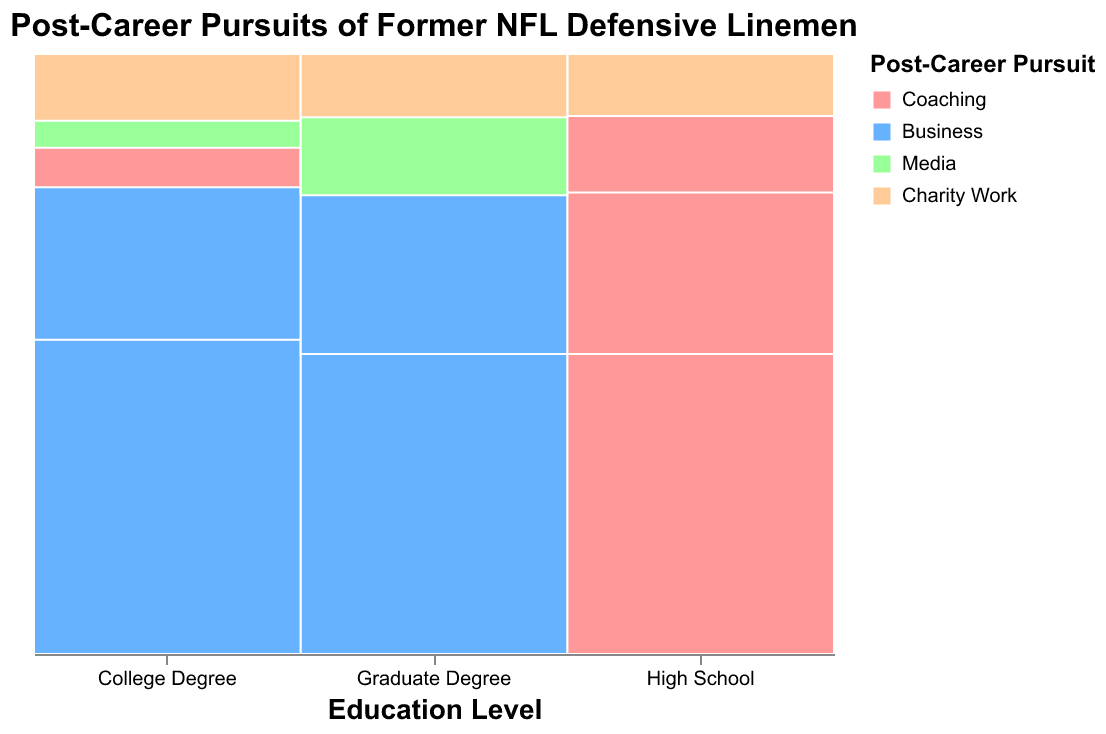What is the title of the figure? The title is displayed at the top of the figure in bold text. It provides the context of what the plot is about.
Answer: Post-Career Pursuits of Former NFL Defensive Linemen What colors represent "Business" and "Charity Work" pursuits? The legend provides a mapping between the colors and pursuit categories. "Business" is represented by blue and "Charity Work" by orange.
Answer: Business: Blue, Charity Work: Orange Which post-career pursuit is most common for defensive linemen with a College Degree who played for 4-7 years? By looking at the section where "College Degree" intersects with "4-7" years played, "Business" has the largest area, indicating it's the most common pursuit.
Answer: Business How many years did defensive linemen with a High School education level, who pursued Media, play? By checking the different sections within "High School" for the color representing Media, we see that they played either 4-7 years or 8+ years.
Answer: 4-7 and 8+ Compare the proportion of defensive linemen with Graduate Degrees who pursued Media and Charity Work. Observe the areas for "Media" and "Charity Work" within the "Graduate Degree" section and compare their relative sizes. Media has a slightly larger area than Charity Work.
Answer: Media > Charity Work Which post-career pursuit has the smallest representation among all groups of defensive linemen? By examining the colors in the Mosaic Plot, "Charity Work" appears the least frequently and with smaller areas across different groups.
Answer: Charity Work What's the most common post-career pursuit for defensive linemen with 1-3 years of playing experience? Look across all education levels for the "1-3 years" category and observe which pursuit color is most prevalent. It appears that "Business" has the most substantial area.
Answer: Business How does the representation of Coaching change across different years played for High School graduates? Observe the "Coaching" sections within "High School" across different "Years Played" categories. The proportion varies but generally remains consistent with peaks at "4-7" years.
Answer: Consistently prominent, peaks at 4-7 years How many defensive linemen with a College Degree pursued Charity Work after playing 8+ years? By looking at the "College Degree" section and the "8+" category, the area corresponding to "Charity Work" is evident, and the count provided is 4.
Answer: 4 Which education level has the most diverse post-career pursuits based on the plot? Diversity can be inferred by the number of different colors (pursuits) represented within an education level. The "College Degree" section shows the largest variety of pursuits.
Answer: College Degree 